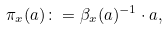<formula> <loc_0><loc_0><loc_500><loc_500>\pi _ { x } ( a ) \colon = \beta _ { x } ( a ) ^ { - 1 } \cdot a ,</formula> 